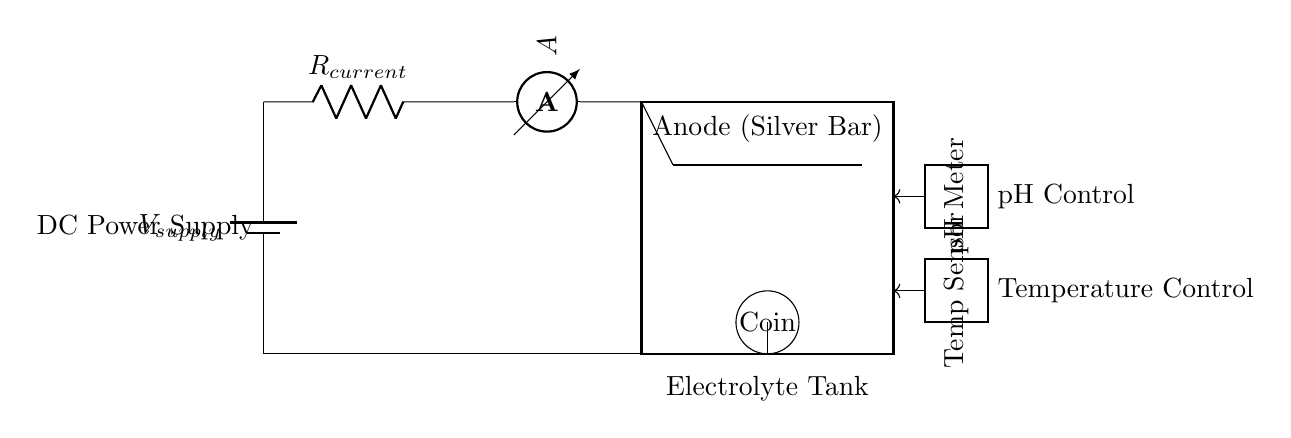What type of power supply is used in this circuit? The circuit uses a direct current (DC) power supply, as indicated by the component labeled "DC Power Supply" in the diagram.
Answer: DC Power Supply What is the role of the silver bar in the electroplating system? The silver bar acts as the anode in the electroplating process, providing the silver ions necessary for the deposition on the cathode (the silver coin).
Answer: Anode What does the ammeter measure in this circuit? The ammeter is used to measure the current flowing through the circuit, which is essential for ensuring the correct electroplating conditions.
Answer: Current How does the pH meter contribute to the electroplating process? The pH meter monitors the acidity or alkalinity of the electrolyte solution, which is crucial for optimal electroplating conditions and the quality of the restored silver coin.
Answer: pH Control What is the significance of the temperature sensor? The temperature sensor is important for monitoring the temperature of the electrolyte solution, as temperature can affect the electroplating efficiency and quality.
Answer: Temperature Control How is the silver coin connected in this circuit? The silver coin is connected as the cathode, which receives silver deposits from the anode during the electroplating process.
Answer: Cathode What could happen if the current is too high during electroplating? If the current is too high, it could lead to poor finishing or damage to the silver coin, as excessive current can cause rough plating or burning of the metal surface.
Answer: Damage 